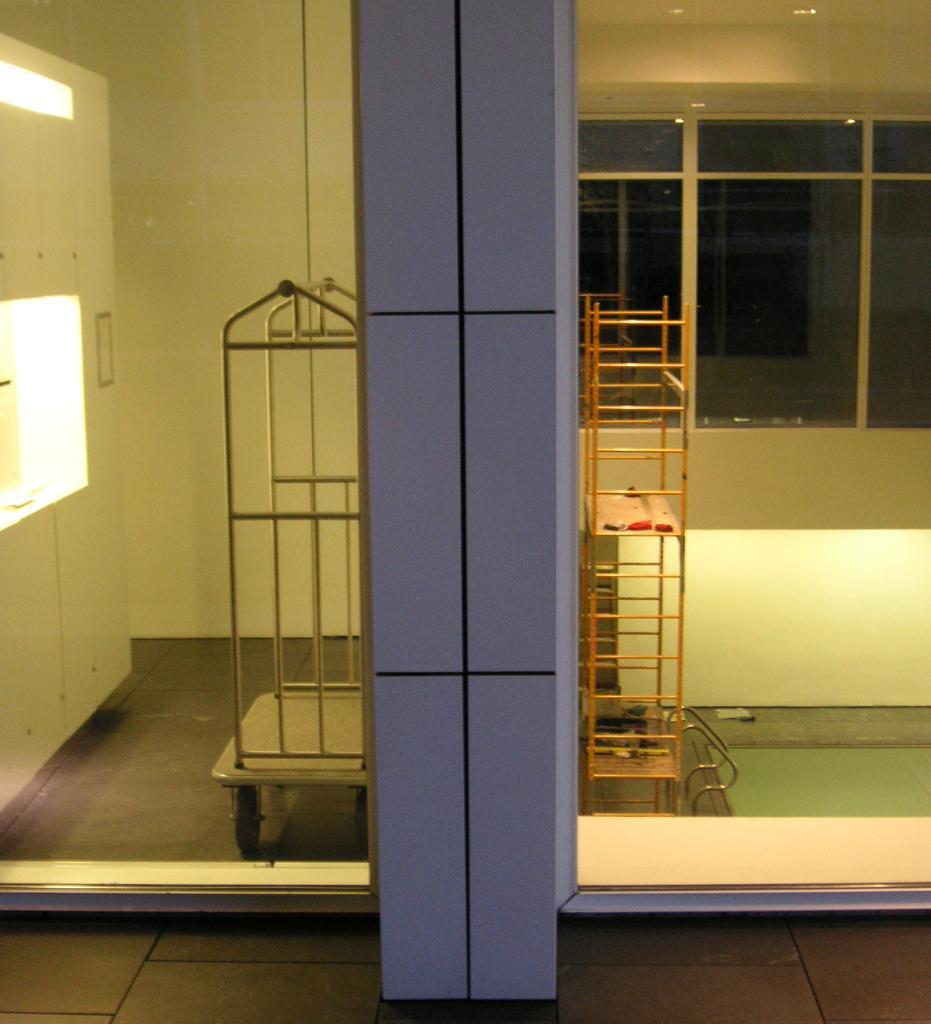Can you describe this image briefly? In the image we can see there are two vehicles kept on the floor and there are windows on the wall. Beside there is a closet. 